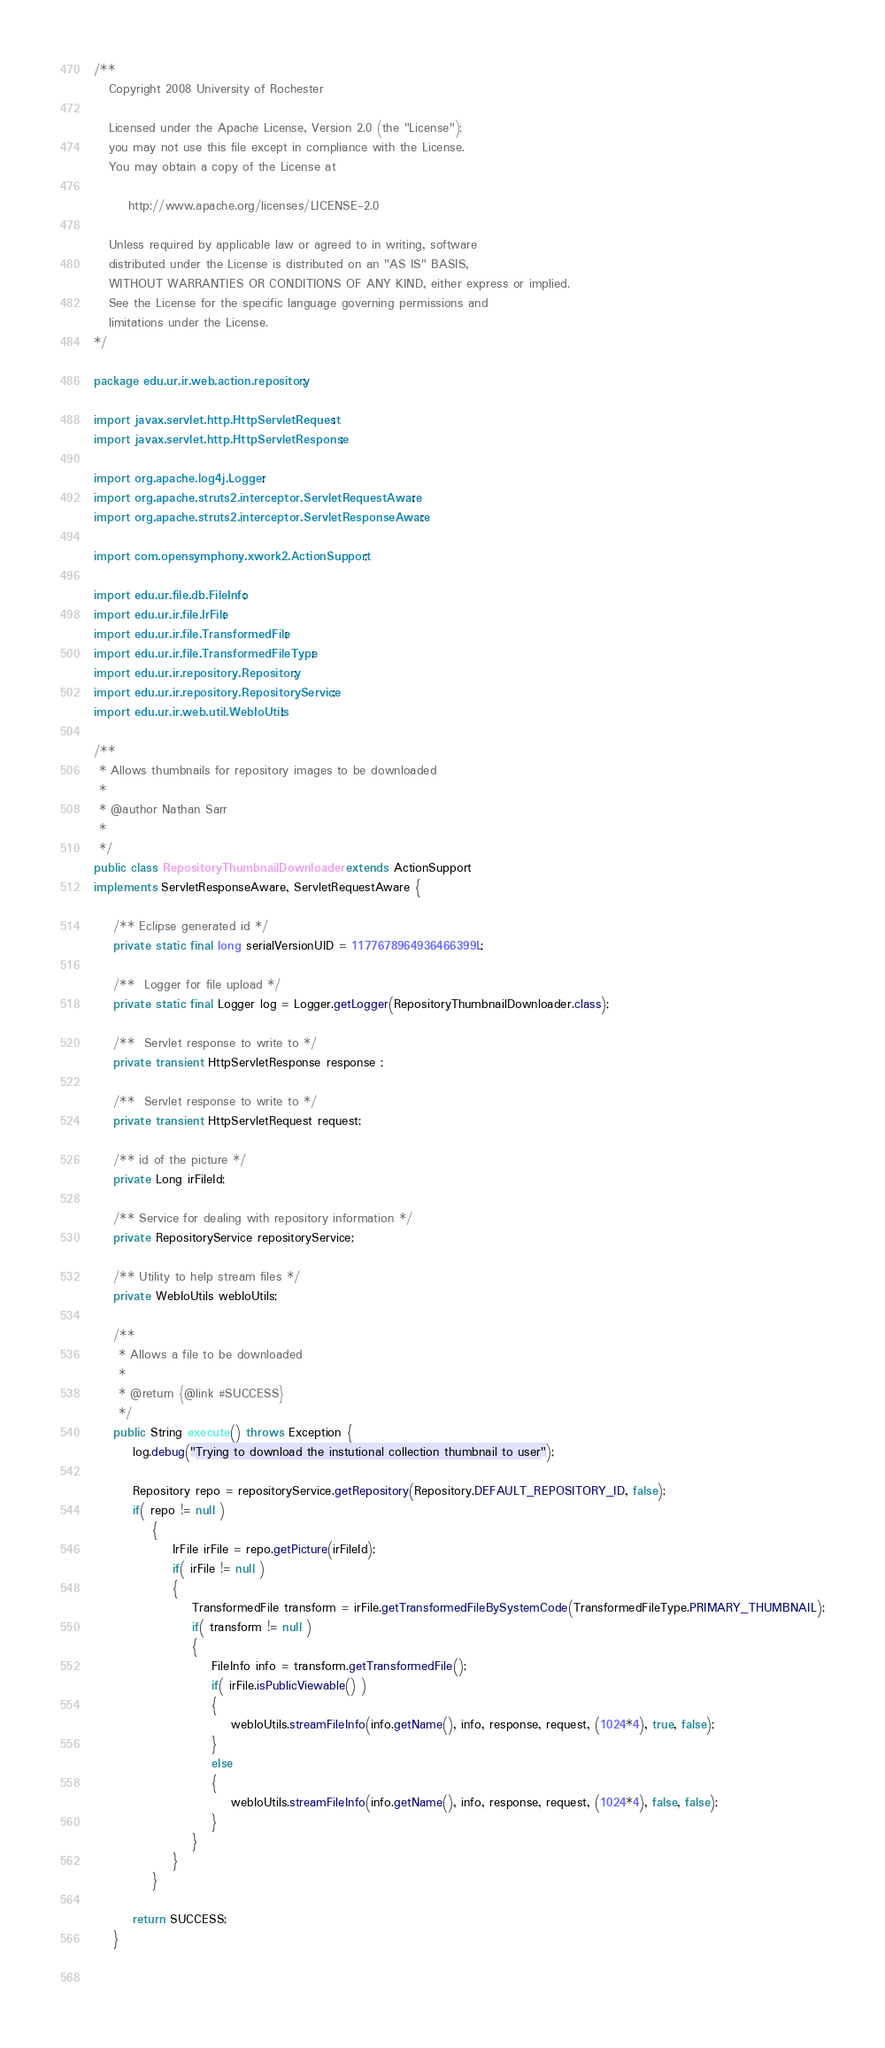Convert code to text. <code><loc_0><loc_0><loc_500><loc_500><_Java_>/**  
   Copyright 2008 University of Rochester

   Licensed under the Apache License, Version 2.0 (the "License");
   you may not use this file except in compliance with the License.
   You may obtain a copy of the License at

       http://www.apache.org/licenses/LICENSE-2.0

   Unless required by applicable law or agreed to in writing, software
   distributed under the License is distributed on an "AS IS" BASIS,
   WITHOUT WARRANTIES OR CONDITIONS OF ANY KIND, either express or implied.
   See the License for the specific language governing permissions and
   limitations under the License.
*/  

package edu.ur.ir.web.action.repository;

import javax.servlet.http.HttpServletRequest;
import javax.servlet.http.HttpServletResponse;

import org.apache.log4j.Logger;
import org.apache.struts2.interceptor.ServletRequestAware;
import org.apache.struts2.interceptor.ServletResponseAware;

import com.opensymphony.xwork2.ActionSupport;

import edu.ur.file.db.FileInfo;
import edu.ur.ir.file.IrFile;
import edu.ur.ir.file.TransformedFile;
import edu.ur.ir.file.TransformedFileType;
import edu.ur.ir.repository.Repository;
import edu.ur.ir.repository.RepositoryService;
import edu.ur.ir.web.util.WebIoUtils;

/**
 * Allows thumbnails for repository images to be downloaded
 * 
 * @author Nathan Sarr
 *
 */
public class RepositoryThumbnailDownloader extends ActionSupport 
implements ServletResponseAware, ServletRequestAware {
	
	/** Eclipse generated id */
	private static final long serialVersionUID = 1177678964936466399L;

	/**  Logger for file upload */
	private static final Logger log = Logger.getLogger(RepositoryThumbnailDownloader.class);

	/**  Servlet response to write to */
	private transient HttpServletResponse response ;
	
	/**  Servlet response to write to */
	private transient HttpServletRequest request;
	
	/** id of the picture */
	private Long irFileId;
	
	/** Service for dealing with repository information */
	private RepositoryService repositoryService;

	/** Utility to help stream files */
	private WebIoUtils webIoUtils;
	
	/**
     * Allows a file to be downloaded
     *
     * @return {@link #SUCCESS}
     */
    public String execute() throws Exception {
    	log.debug("Trying to download the instutional collection thumbnail to user");
    	
        Repository repo = repositoryService.getRepository(Repository.DEFAULT_REPOSITORY_ID, false);
    	if( repo != null )
    		{
    			IrFile irFile = repo.getPicture(irFileId);
    			if( irFile != null )
    			{
    			    TransformedFile transform = irFile.getTransformedFileBySystemCode(TransformedFileType.PRIMARY_THUMBNAIL);
    			    if( transform != null )
    			    {
    				    FileInfo info = transform.getTransformedFile();
    				    if( irFile.isPublicViewable() )
    	    		    {
    	    		        webIoUtils.streamFileInfo(info.getName(), info, response, request, (1024*4), true, false);
    	    		    }
    	    		    else
    	    		    {
    	    			    webIoUtils.streamFileInfo(info.getName(), info, response, request, (1024*4), false, false);
    	    		    }
    			    }
    		    }
    		}
    	
        return SUCCESS;
    }
    
    </code> 